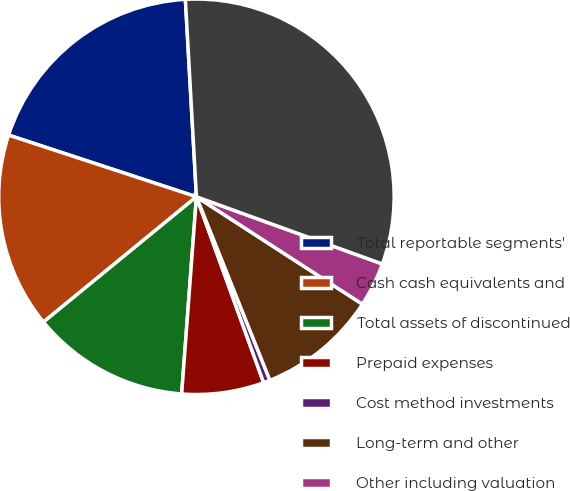Convert chart to OTSL. <chart><loc_0><loc_0><loc_500><loc_500><pie_chart><fcel>Total reportable segments'<fcel>Cash cash equivalents and<fcel>Total assets of discontinued<fcel>Prepaid expenses<fcel>Cost method investments<fcel>Long-term and other<fcel>Other including valuation<fcel>Total assets<nl><fcel>19.06%<fcel>15.97%<fcel>12.89%<fcel>6.71%<fcel>0.54%<fcel>9.8%<fcel>3.62%<fcel>31.41%<nl></chart> 